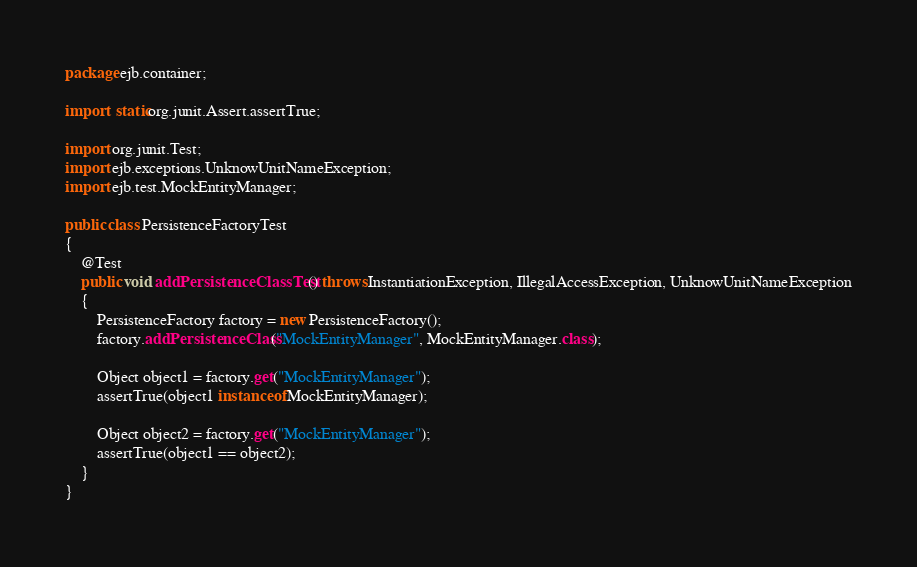<code> <loc_0><loc_0><loc_500><loc_500><_Java_>package ejb.container;

import static org.junit.Assert.assertTrue;

import org.junit.Test;
import ejb.exceptions.UnknowUnitNameException;
import ejb.test.MockEntityManager;

public class PersistenceFactoryTest 
{
	@Test
	public void addPersistenceClassTest() throws InstantiationException, IllegalAccessException, UnknowUnitNameException
	{
		PersistenceFactory factory = new PersistenceFactory();
		factory.addPersistenceClass("MockEntityManager", MockEntityManager.class);
		
		Object object1 = factory.get("MockEntityManager");
		assertTrue(object1 instanceof MockEntityManager);
		
		Object object2 = factory.get("MockEntityManager");
		assertTrue(object1 == object2);
	}
}
</code> 